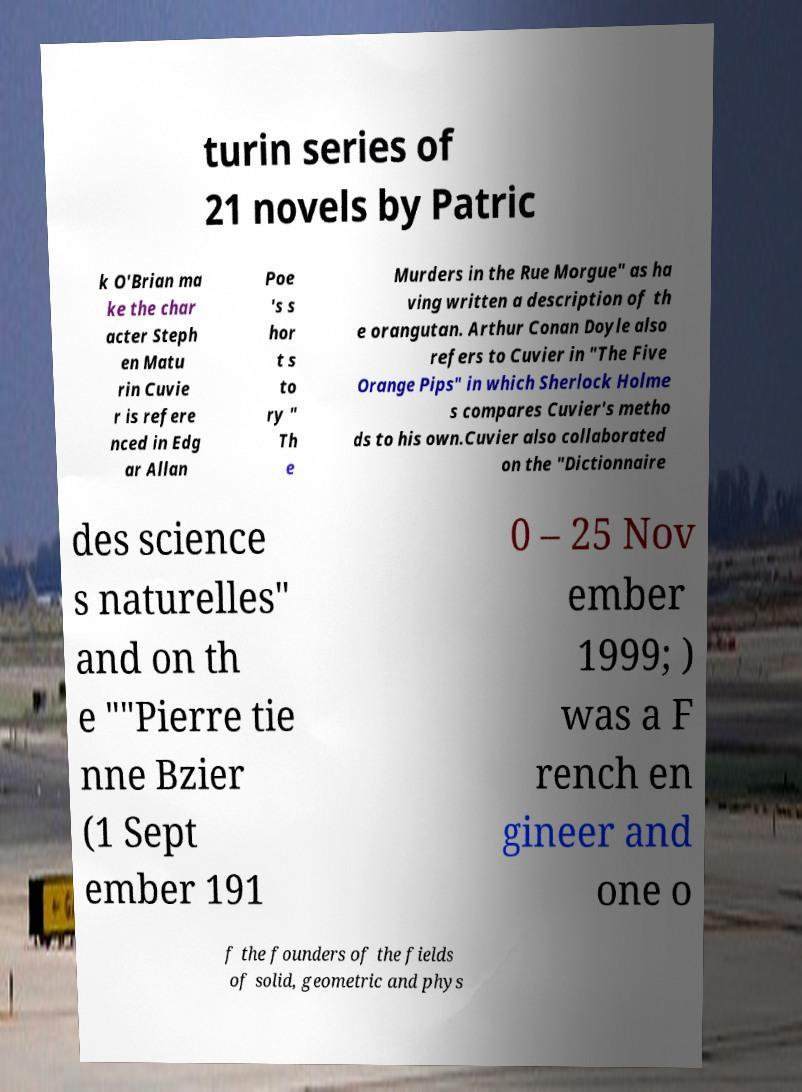Can you read and provide the text displayed in the image?This photo seems to have some interesting text. Can you extract and type it out for me? turin series of 21 novels by Patric k O'Brian ma ke the char acter Steph en Matu rin Cuvie r is refere nced in Edg ar Allan Poe 's s hor t s to ry " Th e Murders in the Rue Morgue" as ha ving written a description of th e orangutan. Arthur Conan Doyle also refers to Cuvier in "The Five Orange Pips" in which Sherlock Holme s compares Cuvier's metho ds to his own.Cuvier also collaborated on the "Dictionnaire des science s naturelles" and on th e ""Pierre tie nne Bzier (1 Sept ember 191 0 – 25 Nov ember 1999; ) was a F rench en gineer and one o f the founders of the fields of solid, geometric and phys 